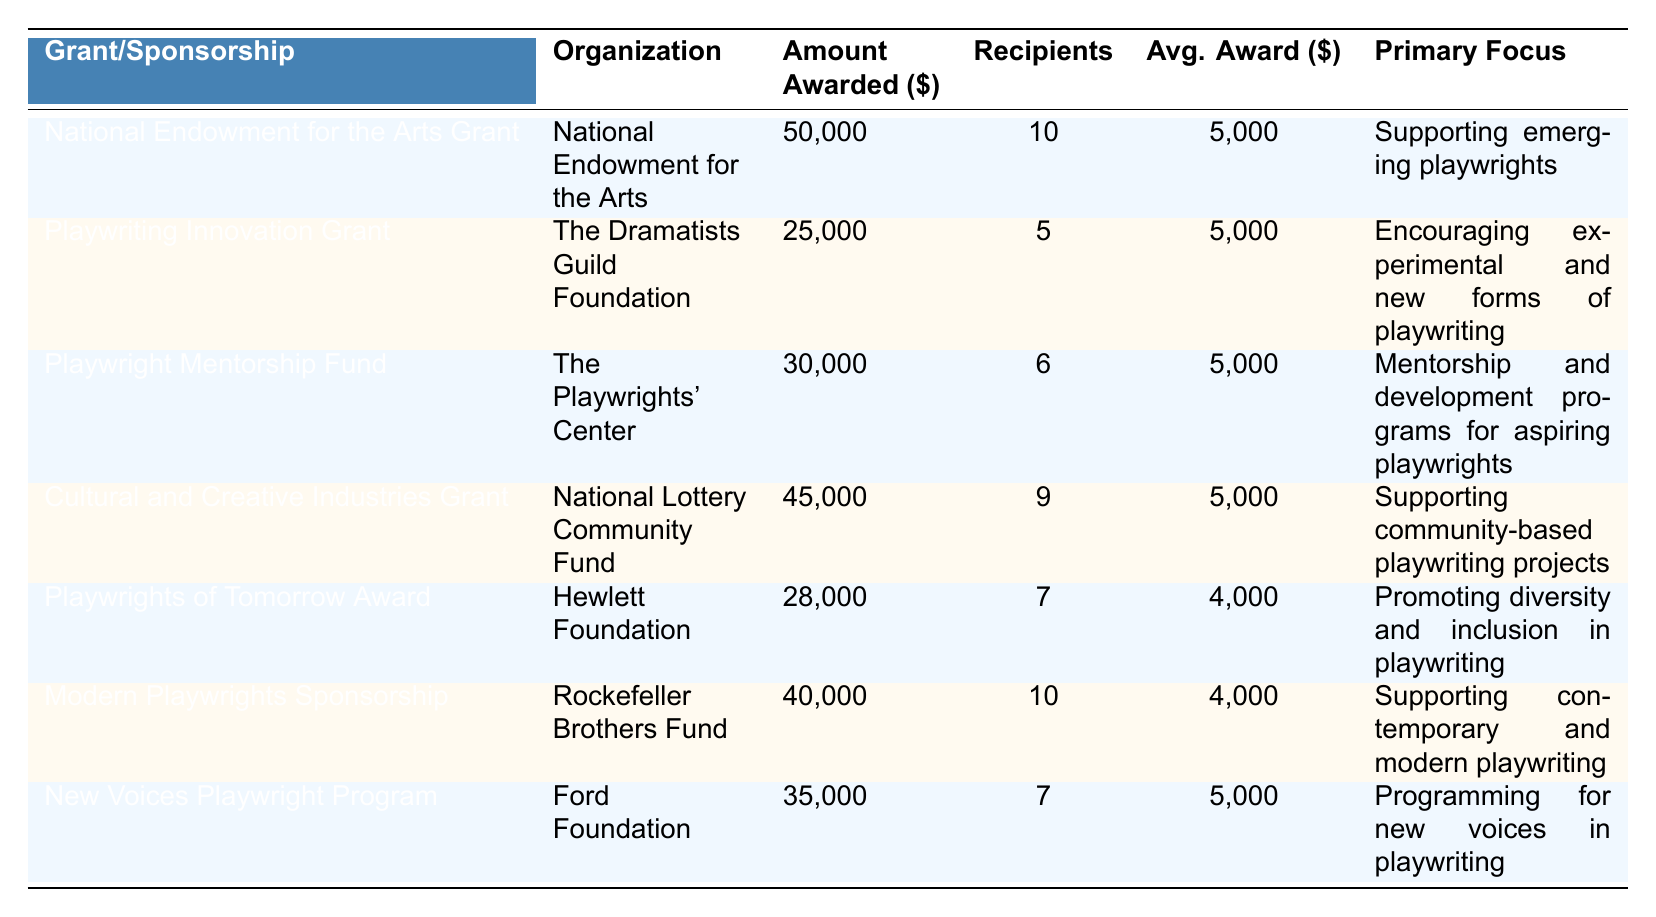What is the organization that awarded the highest amount in grants? The table shows the "National Endowment for the Arts Grant" awarded by the "National Endowment for the Arts" with an amount awarded of $50,000, which is the highest among all entries.
Answer: National Endowment for the Arts How many total recipients were there across all the grants and sponsorships? To find the total recipients, sum the number of recipients from each entry: 10 + 5 + 6 + 9 + 7 + 10 + 7 = 54.
Answer: 54 Is the average award per recipient for the "Playwright Mentorship Fund" different from the average award per recipient for the "Playwriting Innovation Grant"? The average award per recipient for both funds is $5,000. Therefore, the two averages are the same, making the statement false.
Answer: No Which grant has the primary focus of "Mentorship and development programs for aspiring playwrights"? The "Playwright Mentorship Fund" has the primary focus of "Mentorship and development programs for aspiring playwrights," as stated in the table.
Answer: Playwright Mentorship Fund What is the total amount awarded by the "Hewlett Foundation"? The total amount awarded by the "Hewlett Foundation" for the "Playwrights of Tomorrow Award" is $28,000, as listed in the table.
Answer: 28000 Which organization supports "community-based playwriting projects"? The "Cultural and Creative Industries Grant" supports community-based playwriting projects and is awarded by the "National Lottery Community Fund."
Answer: National Lottery Community Fund How does the average award of the "Modern Playwrights Sponsorship" compare to the overall average award per recipient across all grants? The average award for "Modern Playwrights Sponsorship" is $4,000. The overall total amount awarded is $228,000 with a total of 54 recipients. Hence the overall average is $228,000 / 54 ≈ $4,222. Since $4,000 is less than $4,222, the comparison shows it's lower.
Answer: Lower What percentage of the total award amount was given to "Playwriting Innovation Grant" compared to the total amount awarded? The total amount awarded is $228,000. The "Playwriting Innovation Grant" award is $25,000. The percentage is (25,000 / 228,000) * 100 ≈ 10.96%.
Answer: Approximately 10.96% Name the grant that provides support for "experimental and new forms of playwriting." "Playwriting Innovation Grant" is the grant focused on "Encouraging experimental and new forms of playwriting."
Answer: Playwriting Innovation Grant 